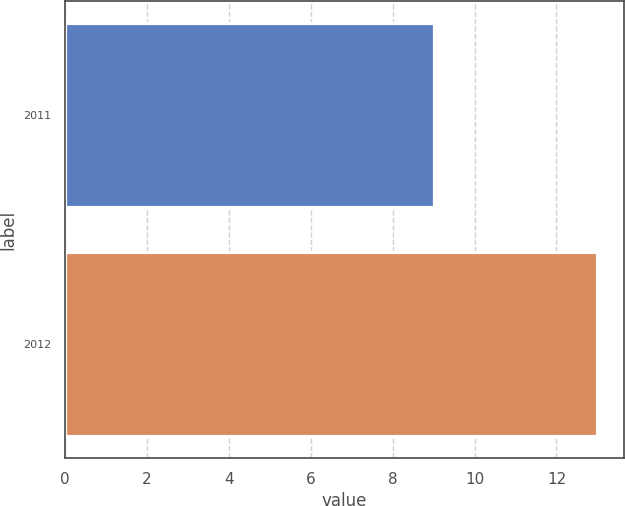Convert chart to OTSL. <chart><loc_0><loc_0><loc_500><loc_500><bar_chart><fcel>2011<fcel>2012<nl><fcel>9<fcel>13<nl></chart> 